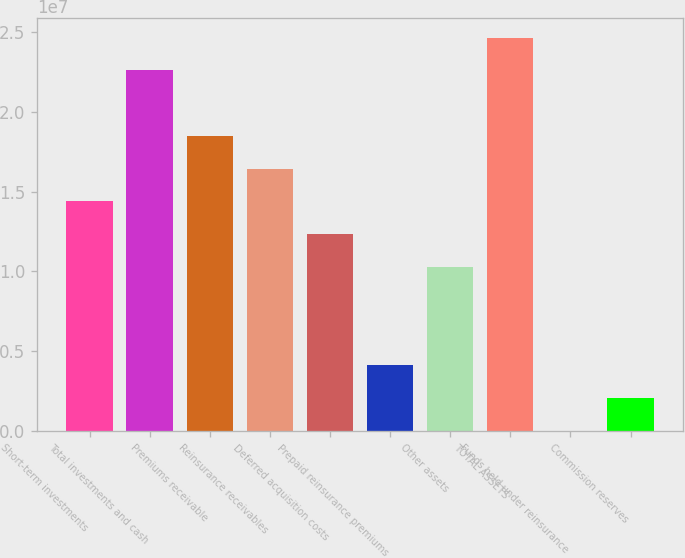<chart> <loc_0><loc_0><loc_500><loc_500><bar_chart><fcel>Short-term investments<fcel>Total investments and cash<fcel>Premiums receivable<fcel>Reinsurance receivables<fcel>Deferred acquisition costs<fcel>Prepaid reinsurance premiums<fcel>Other assets<fcel>TOTAL ASSETS<fcel>Funds held under reinsurance<fcel>Commission reserves<nl><fcel>1.43896e+07<fcel>2.26046e+07<fcel>1.84971e+07<fcel>1.64434e+07<fcel>1.23359e+07<fcel>4.121e+06<fcel>1.02822e+07<fcel>2.46583e+07<fcel>13544<fcel>2.06727e+06<nl></chart> 